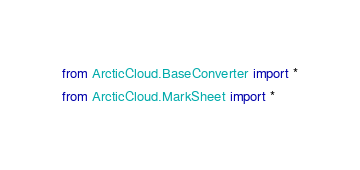<code> <loc_0><loc_0><loc_500><loc_500><_Python_>from ArcticCloud.BaseConverter import *
from ArcticCloud.MarkSheet import *</code> 